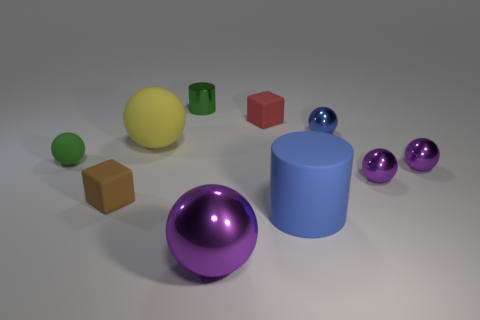Subtract all red cylinders. How many purple balls are left? 3 Subtract all yellow spheres. How many spheres are left? 5 Subtract all matte balls. How many balls are left? 4 Subtract 2 balls. How many balls are left? 4 Subtract all red spheres. Subtract all purple cylinders. How many spheres are left? 6 Subtract all blocks. How many objects are left? 8 Subtract all purple shiny cylinders. Subtract all green things. How many objects are left? 8 Add 8 big shiny balls. How many big shiny balls are left? 9 Add 8 big blue rubber things. How many big blue rubber things exist? 9 Subtract 1 green cylinders. How many objects are left? 9 